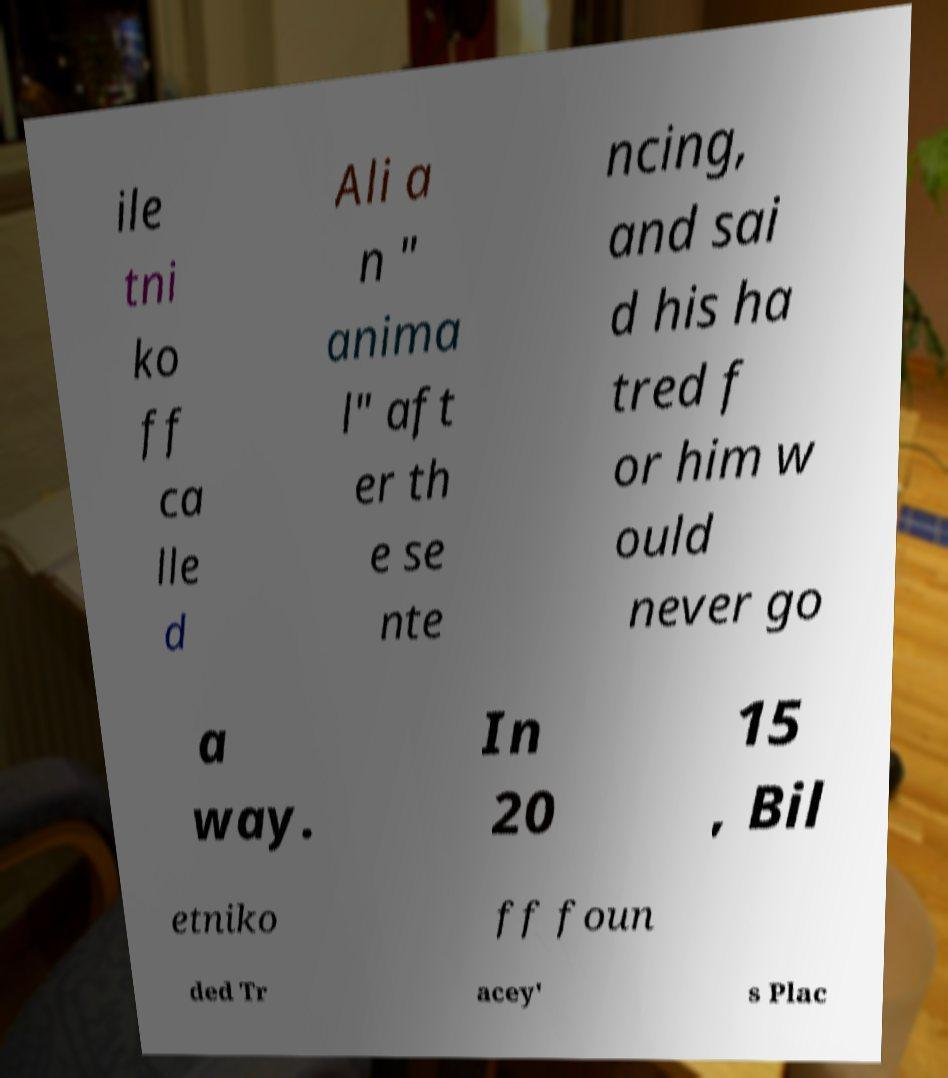For documentation purposes, I need the text within this image transcribed. Could you provide that? ile tni ko ff ca lle d Ali a n " anima l" aft er th e se nte ncing, and sai d his ha tred f or him w ould never go a way. In 20 15 , Bil etniko ff foun ded Tr acey' s Plac 